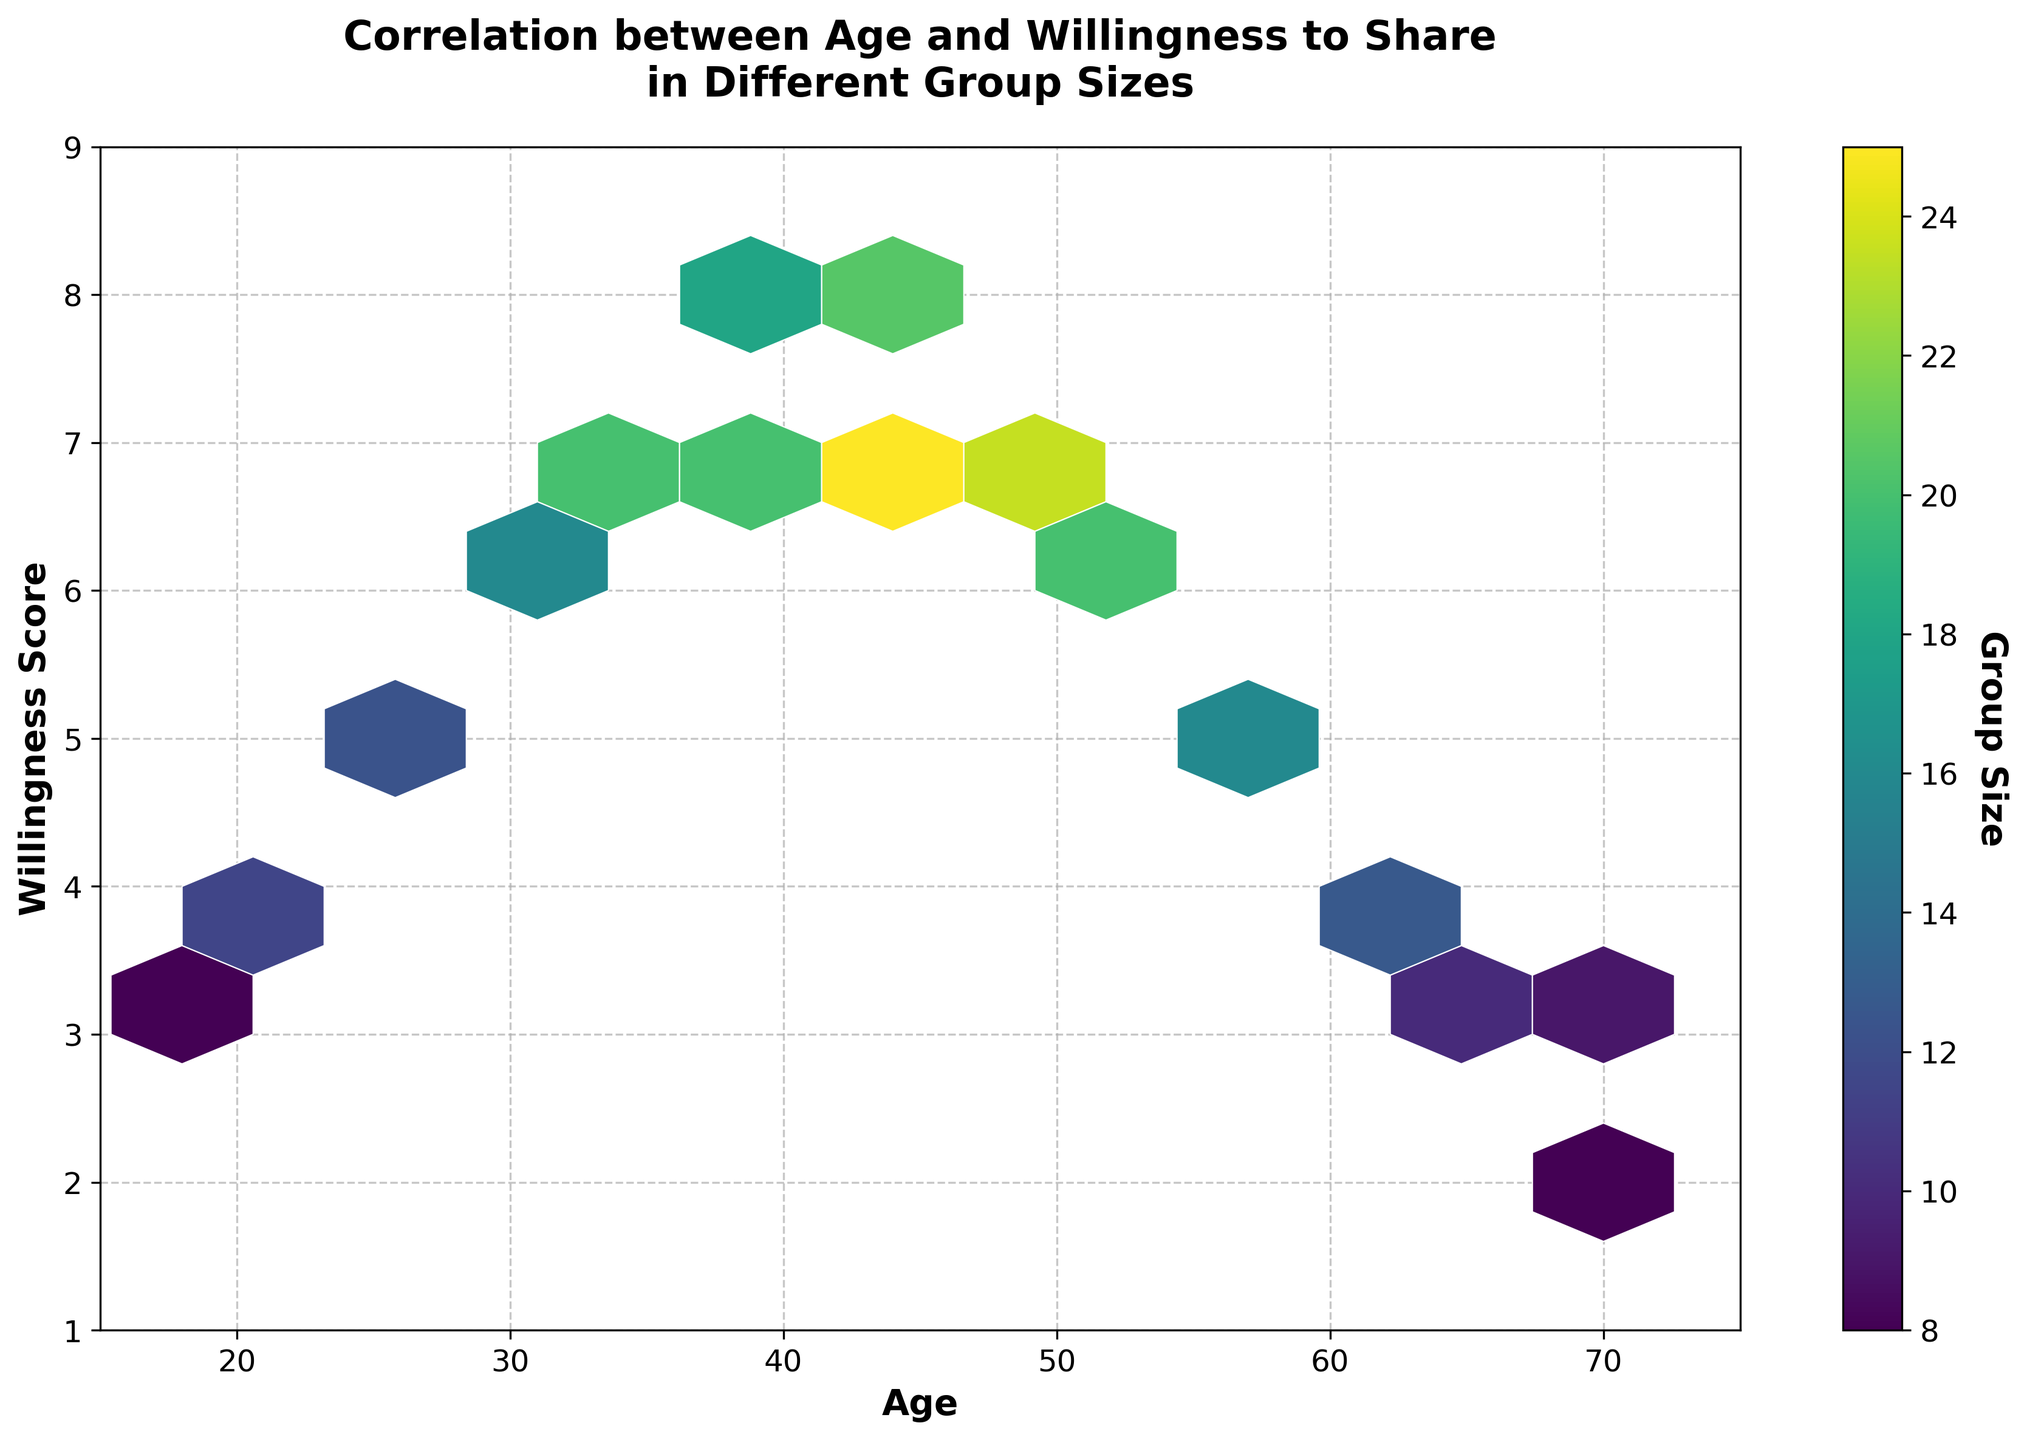What is the title of the plot? The title of the plot is shown prominently at the top of the figure, and it reads "Correlation between Age and Willingness to Share in Different Group Sizes".
Answer: Correlation between Age and Willingness to Share in Different Group Sizes What do the X and Y axes represent? The X-axis is labeled 'Age' and the Y-axis is labeled 'Willingness Score'. These labels are clearly shown on the plot's axes.
Answer: Age and Willingness Score What do the colors represent in the hexbin plot? The colors in the hexbin plot represent the 'Group Size', which is indicated by the color bar on the right side of the plot.
Answer: Group Size What is the range of ages shown in the figure? The X-axis starts at 15 and ends at 75, indicating the range of ages displayed in the plot.
Answer: 15 to 75 Which age group has the highest Willingness Score? From the figure, we see that the highest Willingness Score is 8, and this score is reached by age groups around 40 to 45.
Answer: 40 to 45 How is the willingness to share experiences related to age as seen in the plot? As age increases, the willingness to share experiences also increases up to a point around 40-45 years old, after which it decreases again. This can be observed from the hexbin density and color variations in the plot.
Answer: Increases up to 40-45, then decreases Which group size appears most frequently in the plot? The color bar indicates the frequency of group sizes, and it looks like the group size of around 14-16 appears frequently, evidenced by more green-to-yellow hexagons in this range.
Answer: 14-16 Is there a noticeable pattern in the willingness scores with respect to different group sizes? Higher Willingness Scores are typically associated with mid-range group sizes (near 15-20), while lower Willingness Scores are often associated with smaller group sizes. This pattern can be inferred from the color gradients in the plot.
Answer: Higher scores with mid-range group sizes What is the relationship between the highest Willingness Scores and the group sizes? The highest Willingness Scores (7-8) are associated with larger group sizes, generally around 18-22. This relationship is visible from the denser yellow regions in the plot.
Answer: Larger group sizes (18-22) How does the willingness to share in group settings change for individuals over 50 years old? For individuals over 50 years old, the willingness to share in group settings decreases, as indicated by the declining scores after this age group. This can be seen from the progression of hexbin density and colors moving towards lower scores.
Answer: Decreases 